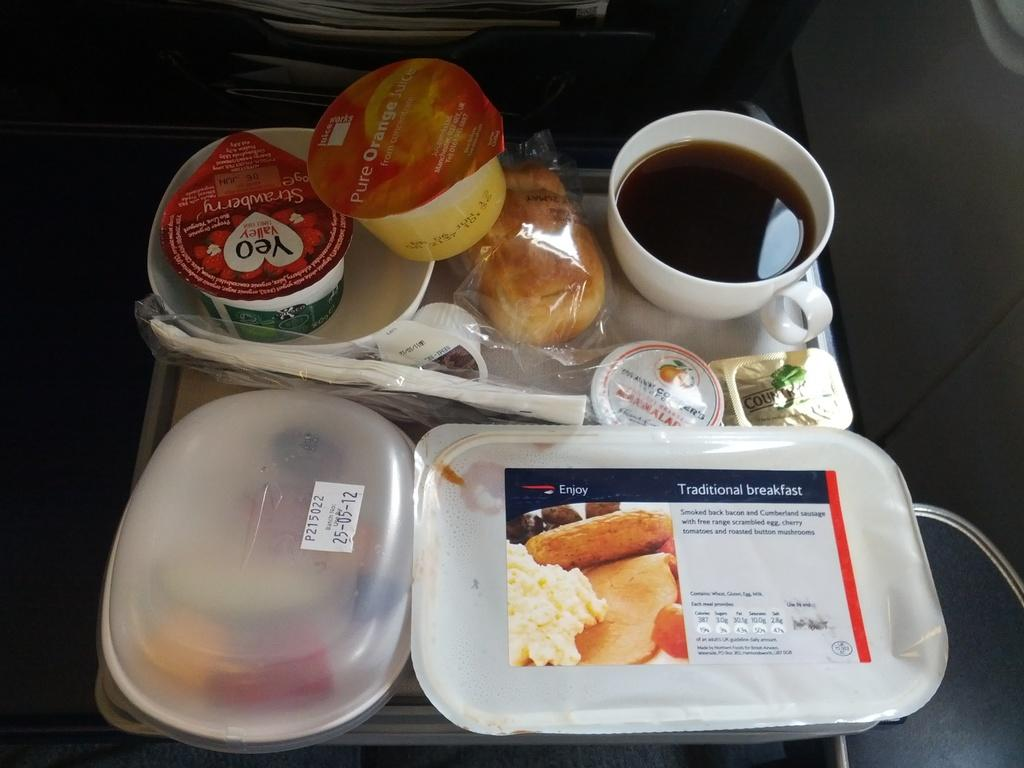What type of objects can be seen in the image? There are food items in the image. How are the food items presented? The food items are packed. What type of gold item is being held by the boy in the image? There is no boy or gold item present in the image; it only features packed food items. What type of pickle is visible in the image? There is no pickle present in the image; it only features packed food items. 